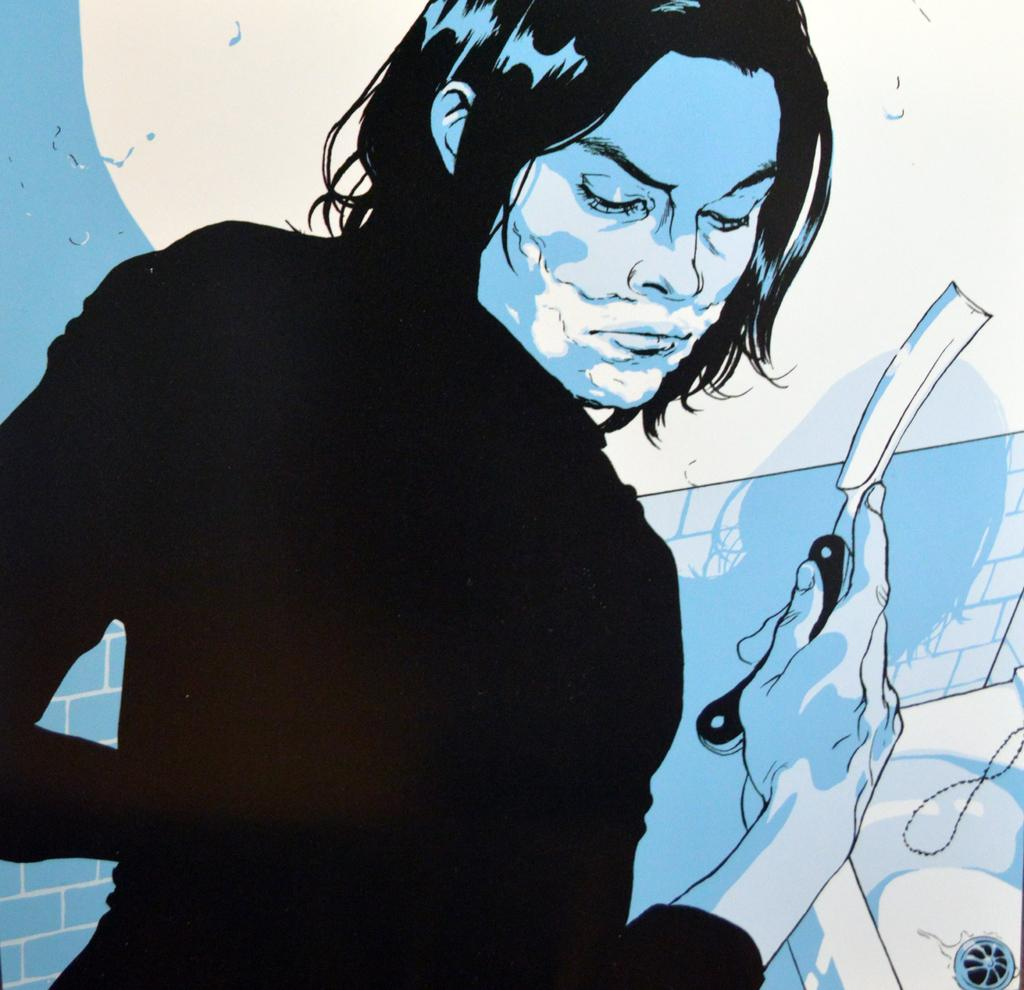What is present in the image? There is a person in the image. What is the person doing in the image? The person is holding an object in their hand. What can be seen in the background of the image? There is a sink and a wall in the image. What type of artwork is the image? The image appears to be a painting. What hobbies does the person in the image have? There is no information about the person's hobbies in the image. How much sugar is in the line of the painting? There is no line of sugar in the image, as it is a painting of a person holding an object. 